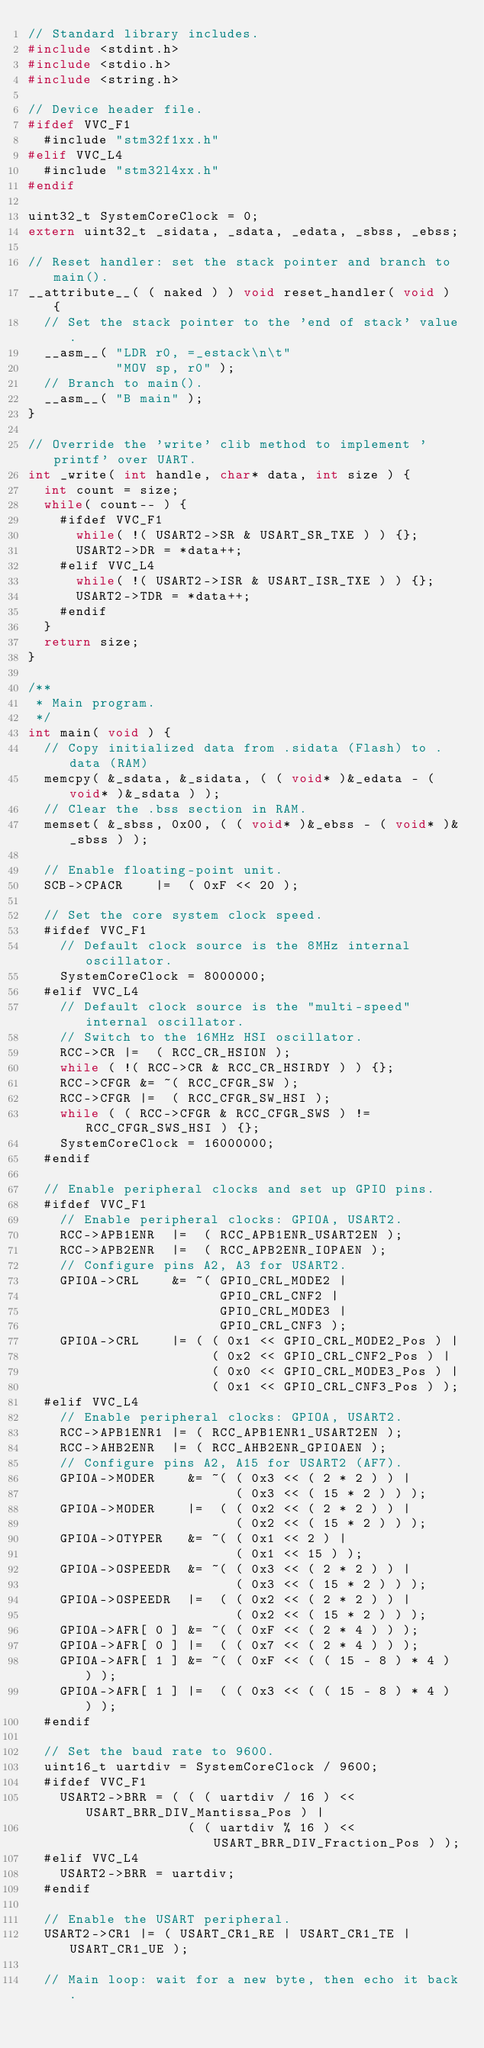<code> <loc_0><loc_0><loc_500><loc_500><_C_>// Standard library includes.
#include <stdint.h>
#include <stdio.h>
#include <string.h>

// Device header file.
#ifdef VVC_F1
  #include "stm32f1xx.h"
#elif VVC_L4
  #include "stm32l4xx.h"
#endif

uint32_t SystemCoreClock = 0;
extern uint32_t _sidata, _sdata, _edata, _sbss, _ebss;

// Reset handler: set the stack pointer and branch to main().
__attribute__( ( naked ) ) void reset_handler( void ) {
  // Set the stack pointer to the 'end of stack' value.
  __asm__( "LDR r0, =_estack\n\t"
           "MOV sp, r0" );
  // Branch to main().
  __asm__( "B main" );
}

// Override the 'write' clib method to implement 'printf' over UART.
int _write( int handle, char* data, int size ) {
  int count = size;
  while( count-- ) {
    #ifdef VVC_F1
      while( !( USART2->SR & USART_SR_TXE ) ) {};
      USART2->DR = *data++;
    #elif VVC_L4
      while( !( USART2->ISR & USART_ISR_TXE ) ) {};
      USART2->TDR = *data++;
    #endif
  }
  return size;
}

/**
 * Main program.
 */
int main( void ) {
  // Copy initialized data from .sidata (Flash) to .data (RAM)
  memcpy( &_sdata, &_sidata, ( ( void* )&_edata - ( void* )&_sdata ) );
  // Clear the .bss section in RAM.
  memset( &_sbss, 0x00, ( ( void* )&_ebss - ( void* )&_sbss ) );

  // Enable floating-point unit.
  SCB->CPACR    |=  ( 0xF << 20 );

  // Set the core system clock speed.
  #ifdef VVC_F1
    // Default clock source is the 8MHz internal oscillator.
    SystemCoreClock = 8000000;
  #elif VVC_L4
    // Default clock source is the "multi-speed" internal oscillator.
    // Switch to the 16MHz HSI oscillator.
    RCC->CR |=  ( RCC_CR_HSION );
    while ( !( RCC->CR & RCC_CR_HSIRDY ) ) {};
    RCC->CFGR &= ~( RCC_CFGR_SW );
    RCC->CFGR |=  ( RCC_CFGR_SW_HSI );
    while ( ( RCC->CFGR & RCC_CFGR_SWS ) != RCC_CFGR_SWS_HSI ) {};
    SystemCoreClock = 16000000;
  #endif

  // Enable peripheral clocks and set up GPIO pins.
  #ifdef VVC_F1
    // Enable peripheral clocks: GPIOA, USART2.
    RCC->APB1ENR  |=  ( RCC_APB1ENR_USART2EN );
    RCC->APB2ENR  |=  ( RCC_APB2ENR_IOPAEN );
    // Configure pins A2, A3 for USART2.
    GPIOA->CRL    &= ~( GPIO_CRL_MODE2 |
                        GPIO_CRL_CNF2 |
                        GPIO_CRL_MODE3 |
                        GPIO_CRL_CNF3 );
    GPIOA->CRL    |= ( ( 0x1 << GPIO_CRL_MODE2_Pos ) |
                       ( 0x2 << GPIO_CRL_CNF2_Pos ) |
                       ( 0x0 << GPIO_CRL_MODE3_Pos ) |
                       ( 0x1 << GPIO_CRL_CNF3_Pos ) );
  #elif VVC_L4
    // Enable peripheral clocks: GPIOA, USART2.
    RCC->APB1ENR1 |= ( RCC_APB1ENR1_USART2EN );
    RCC->AHB2ENR  |= ( RCC_AHB2ENR_GPIOAEN );
    // Configure pins A2, A15 for USART2 (AF7).
    GPIOA->MODER    &= ~( ( 0x3 << ( 2 * 2 ) ) |
                          ( 0x3 << ( 15 * 2 ) ) );
    GPIOA->MODER    |=  ( ( 0x2 << ( 2 * 2 ) ) |
                          ( 0x2 << ( 15 * 2 ) ) );
    GPIOA->OTYPER   &= ~( ( 0x1 << 2 ) |
                          ( 0x1 << 15 ) );
    GPIOA->OSPEEDR  &= ~( ( 0x3 << ( 2 * 2 ) ) |
                          ( 0x3 << ( 15 * 2 ) ) );
    GPIOA->OSPEEDR  |=  ( ( 0x2 << ( 2 * 2 ) ) |
                          ( 0x2 << ( 15 * 2 ) ) );
    GPIOA->AFR[ 0 ] &= ~( ( 0xF << ( 2 * 4 ) ) );
    GPIOA->AFR[ 0 ] |=  ( ( 0x7 << ( 2 * 4 ) ) );
    GPIOA->AFR[ 1 ] &= ~( ( 0xF << ( ( 15 - 8 ) * 4 ) ) );
    GPIOA->AFR[ 1 ] |=  ( ( 0x3 << ( ( 15 - 8 ) * 4 ) ) );
  #endif

  // Set the baud rate to 9600.
  uint16_t uartdiv = SystemCoreClock / 9600;
  #ifdef VVC_F1
    USART2->BRR = ( ( ( uartdiv / 16 ) << USART_BRR_DIV_Mantissa_Pos ) |
                    ( ( uartdiv % 16 ) << USART_BRR_DIV_Fraction_Pos ) );
  #elif VVC_L4
    USART2->BRR = uartdiv;
  #endif

  // Enable the USART peripheral.
  USART2->CR1 |= ( USART_CR1_RE | USART_CR1_TE | USART_CR1_UE );

  // Main loop: wait for a new byte, then echo it back.</code> 